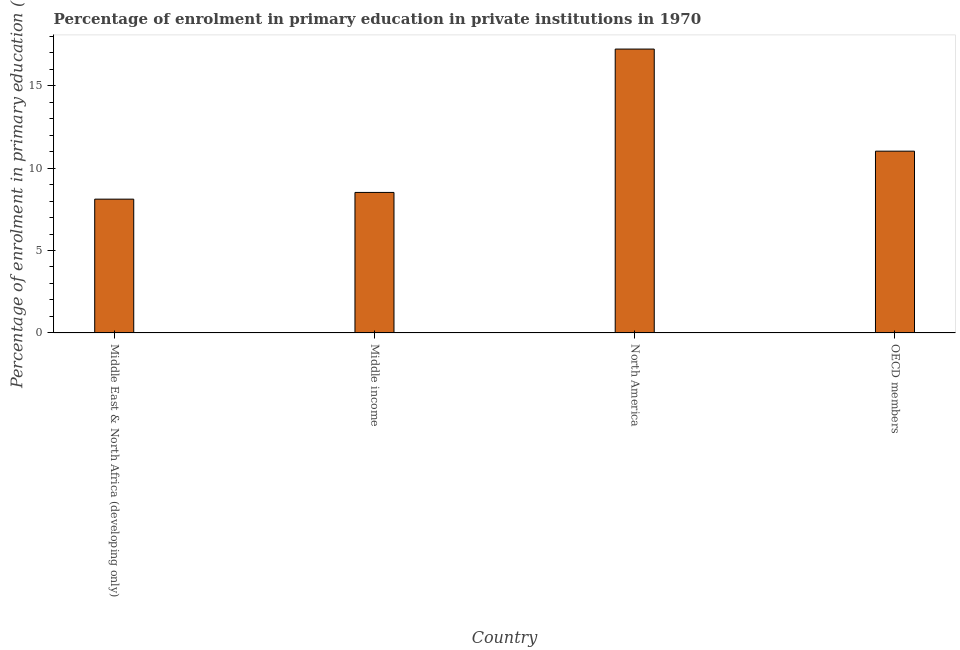Does the graph contain any zero values?
Provide a succinct answer. No. Does the graph contain grids?
Your answer should be compact. No. What is the title of the graph?
Ensure brevity in your answer.  Percentage of enrolment in primary education in private institutions in 1970. What is the label or title of the X-axis?
Your answer should be compact. Country. What is the label or title of the Y-axis?
Your answer should be compact. Percentage of enrolment in primary education (%). What is the enrolment percentage in primary education in Middle East & North Africa (developing only)?
Make the answer very short. 8.12. Across all countries, what is the maximum enrolment percentage in primary education?
Your response must be concise. 17.22. Across all countries, what is the minimum enrolment percentage in primary education?
Provide a short and direct response. 8.12. In which country was the enrolment percentage in primary education maximum?
Make the answer very short. North America. In which country was the enrolment percentage in primary education minimum?
Your response must be concise. Middle East & North Africa (developing only). What is the sum of the enrolment percentage in primary education?
Keep it short and to the point. 44.88. What is the difference between the enrolment percentage in primary education in Middle East & North Africa (developing only) and Middle income?
Offer a terse response. -0.41. What is the average enrolment percentage in primary education per country?
Your answer should be compact. 11.22. What is the median enrolment percentage in primary education?
Keep it short and to the point. 9.77. What is the ratio of the enrolment percentage in primary education in Middle income to that in North America?
Make the answer very short. 0.49. Is the difference between the enrolment percentage in primary education in Middle East & North Africa (developing only) and North America greater than the difference between any two countries?
Make the answer very short. Yes. What is the difference between the highest and the second highest enrolment percentage in primary education?
Give a very brief answer. 6.19. What is the difference between the highest and the lowest enrolment percentage in primary education?
Offer a very short reply. 9.1. How many bars are there?
Provide a short and direct response. 4. Are the values on the major ticks of Y-axis written in scientific E-notation?
Ensure brevity in your answer.  No. What is the Percentage of enrolment in primary education (%) in Middle East & North Africa (developing only)?
Your answer should be compact. 8.12. What is the Percentage of enrolment in primary education (%) of Middle income?
Your response must be concise. 8.52. What is the Percentage of enrolment in primary education (%) in North America?
Your answer should be very brief. 17.22. What is the Percentage of enrolment in primary education (%) of OECD members?
Your answer should be compact. 11.03. What is the difference between the Percentage of enrolment in primary education (%) in Middle East & North Africa (developing only) and Middle income?
Offer a terse response. -0.41. What is the difference between the Percentage of enrolment in primary education (%) in Middle East & North Africa (developing only) and North America?
Your response must be concise. -9.1. What is the difference between the Percentage of enrolment in primary education (%) in Middle East & North Africa (developing only) and OECD members?
Your answer should be very brief. -2.91. What is the difference between the Percentage of enrolment in primary education (%) in Middle income and North America?
Offer a very short reply. -8.7. What is the difference between the Percentage of enrolment in primary education (%) in Middle income and OECD members?
Make the answer very short. -2.5. What is the difference between the Percentage of enrolment in primary education (%) in North America and OECD members?
Your response must be concise. 6.19. What is the ratio of the Percentage of enrolment in primary education (%) in Middle East & North Africa (developing only) to that in Middle income?
Ensure brevity in your answer.  0.95. What is the ratio of the Percentage of enrolment in primary education (%) in Middle East & North Africa (developing only) to that in North America?
Provide a succinct answer. 0.47. What is the ratio of the Percentage of enrolment in primary education (%) in Middle East & North Africa (developing only) to that in OECD members?
Offer a terse response. 0.74. What is the ratio of the Percentage of enrolment in primary education (%) in Middle income to that in North America?
Provide a short and direct response. 0.49. What is the ratio of the Percentage of enrolment in primary education (%) in Middle income to that in OECD members?
Your response must be concise. 0.77. What is the ratio of the Percentage of enrolment in primary education (%) in North America to that in OECD members?
Your answer should be very brief. 1.56. 